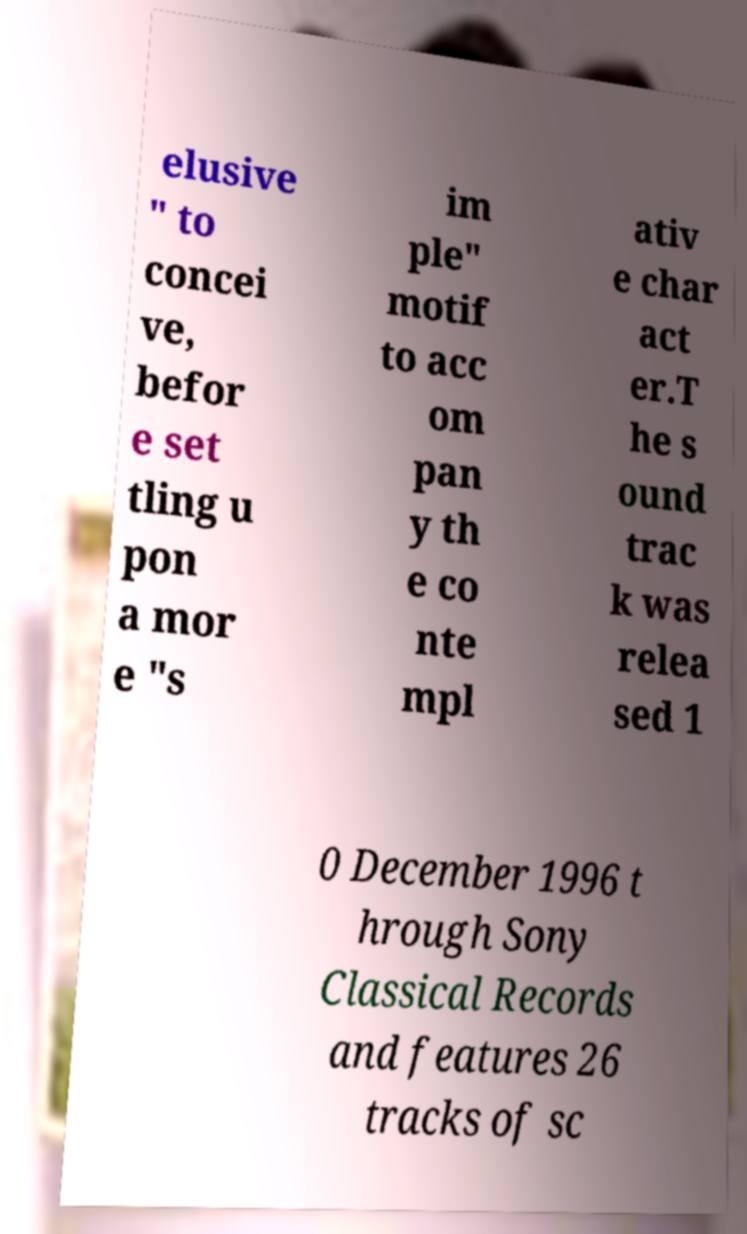For documentation purposes, I need the text within this image transcribed. Could you provide that? elusive " to concei ve, befor e set tling u pon a mor e "s im ple" motif to acc om pan y th e co nte mpl ativ e char act er.T he s ound trac k was relea sed 1 0 December 1996 t hrough Sony Classical Records and features 26 tracks of sc 